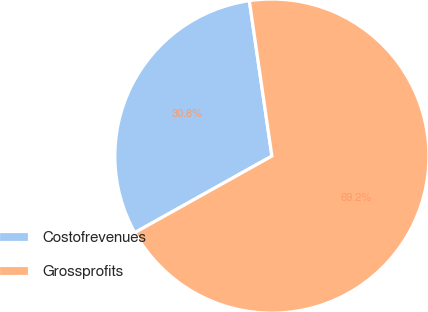<chart> <loc_0><loc_0><loc_500><loc_500><pie_chart><fcel>Costofrevenues<fcel>Grossprofits<nl><fcel>30.81%<fcel>69.19%<nl></chart> 